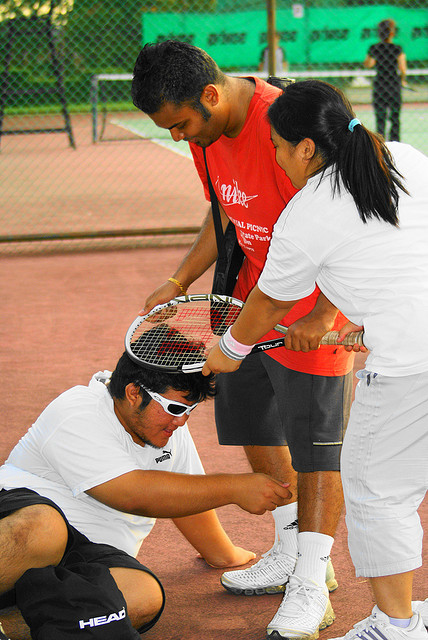What kind of attire do the people in the image wear for playing tennis? The individuals in the photo are dressed in athletic wear suitable for a tennis match. This includes t-shirts, sports shorts, and tennis shoes, designed for comfort and ease of movement during the game. 